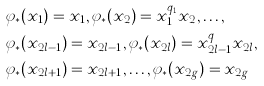Convert formula to latex. <formula><loc_0><loc_0><loc_500><loc_500>& \varphi _ { * } ( x _ { 1 } ) = x _ { 1 } , \varphi _ { * } ( x _ { 2 } ) = x _ { 1 } ^ { q _ { 1 } } x _ { 2 } , \dots , \\ & \varphi _ { * } ( x _ { 2 l - 1 } ) = x _ { 2 l - 1 } , \varphi _ { * } ( x _ { 2 l } ) = x _ { 2 l - 1 } ^ { q _ { l } } x _ { 2 l } , \\ & \varphi _ { * } ( x _ { 2 l + 1 } ) = x _ { 2 l + 1 } , \dots , \varphi _ { * } ( x _ { 2 g } ) = x _ { 2 g }</formula> 